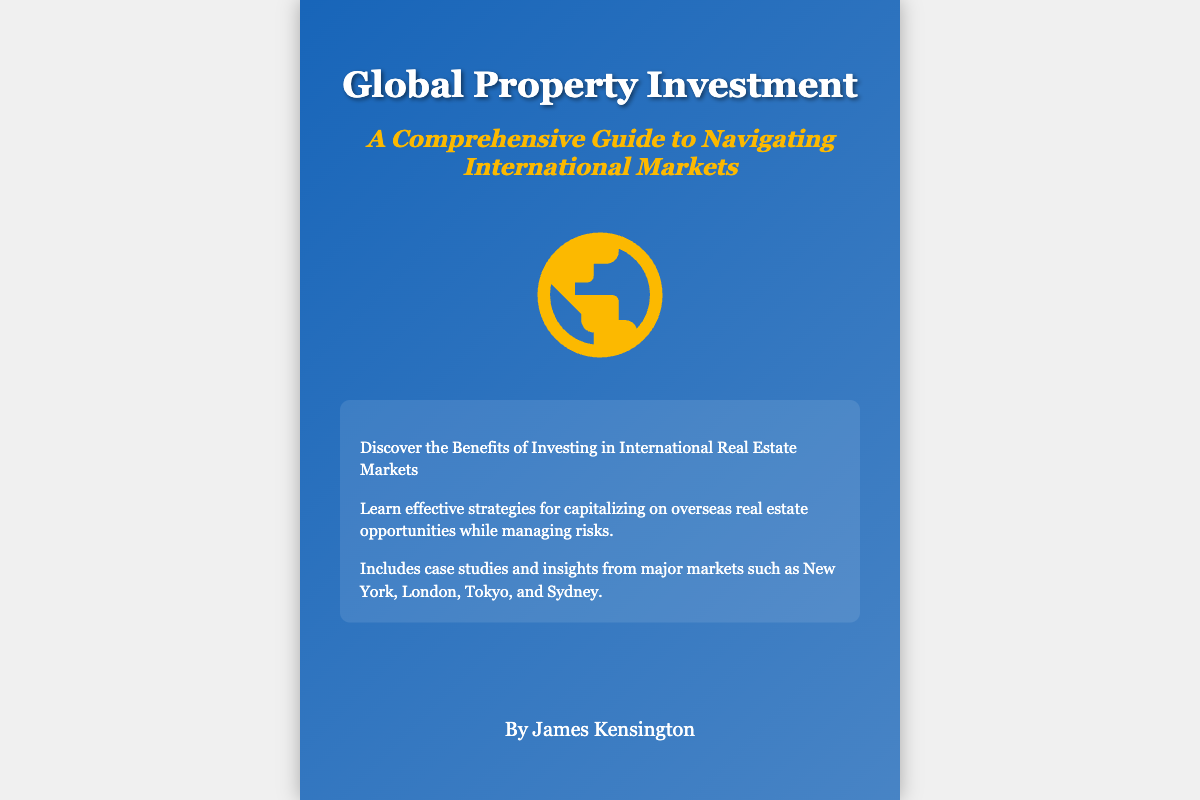What is the title of the book? The title of the book is prominently displayed at the top of the cover.
Answer: Global Property Investment Who is the author of the book? The author's name is listed at the bottom of the cover.
Answer: James Kensington What is the subtitle of the book? The subtitle provides a further description of the book's content, found just below the title.
Answer: A Comprehensive Guide to Navigating International Markets How many highlights are listed on the cover? The number of highlight items can be counted from the list shown on the cover.
Answer: Three What type of markets does the book focus on? The book covers specific real estate markets mentioned in the highlights.
Answer: International What color is the subtitle text? The color of the subtitle is mentioned in the design description.
Answer: Yellow Which city is NOT mentioned in the case studies? The case study highlights list specific cities, of which this one is not included.
Answer: Paris What kind of strategies does the book discuss? The strategies mentioned are related to a specific aspect of real estate investment.
Answer: Effective strategies What is the background image of the book cover? The background image is described in the style section of the document.
Answer: World map with property icons 